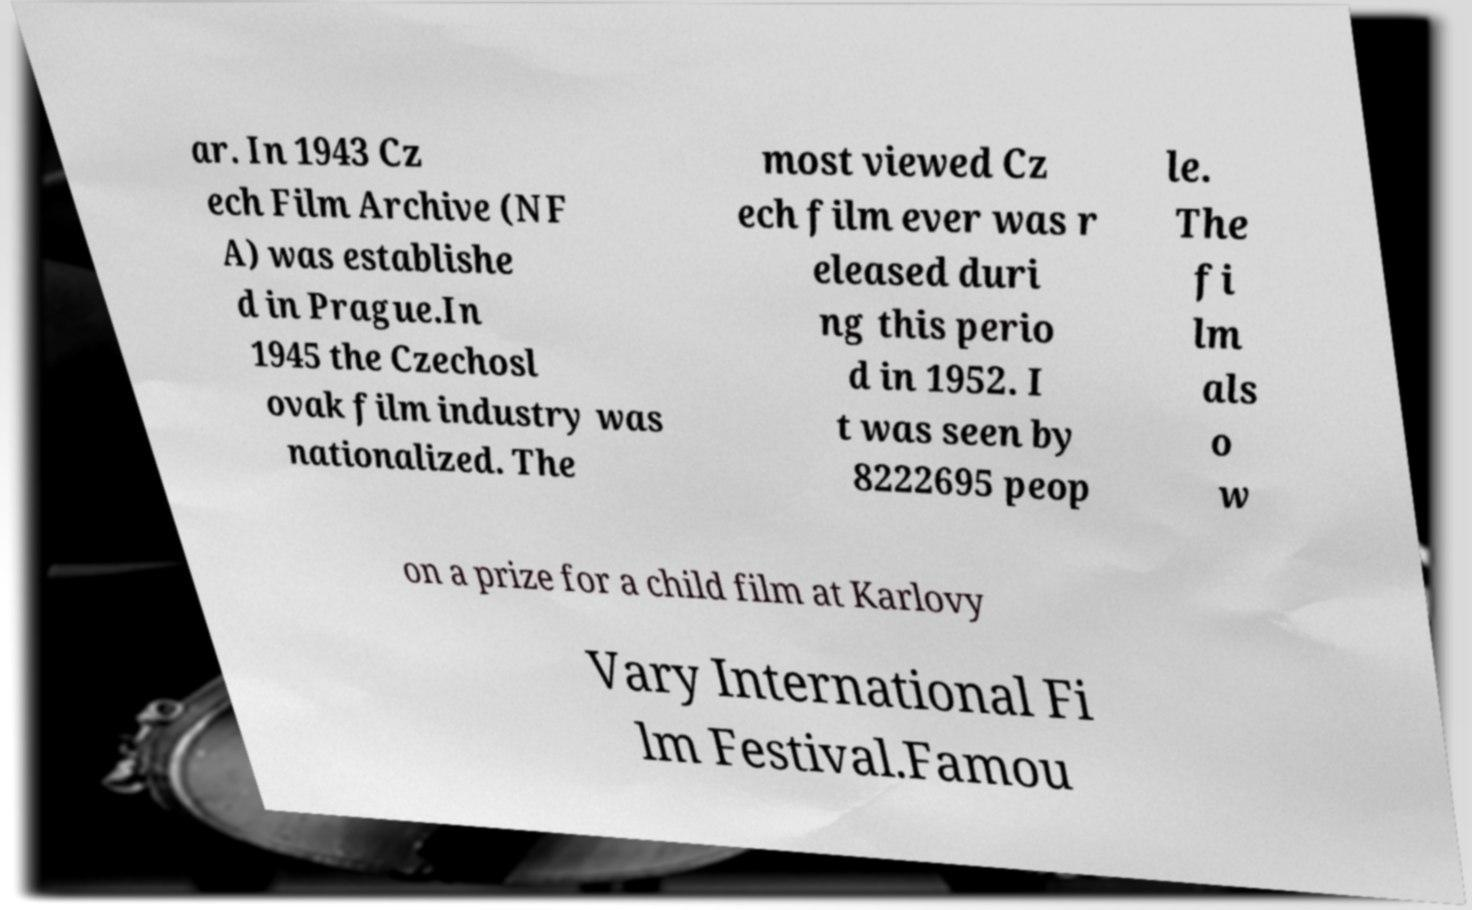For documentation purposes, I need the text within this image transcribed. Could you provide that? ar. In 1943 Cz ech Film Archive (NF A) was establishe d in Prague.In 1945 the Czechosl ovak film industry was nationalized. The most viewed Cz ech film ever was r eleased duri ng this perio d in 1952. I t was seen by 8222695 peop le. The fi lm als o w on a prize for a child film at Karlovy Vary International Fi lm Festival.Famou 